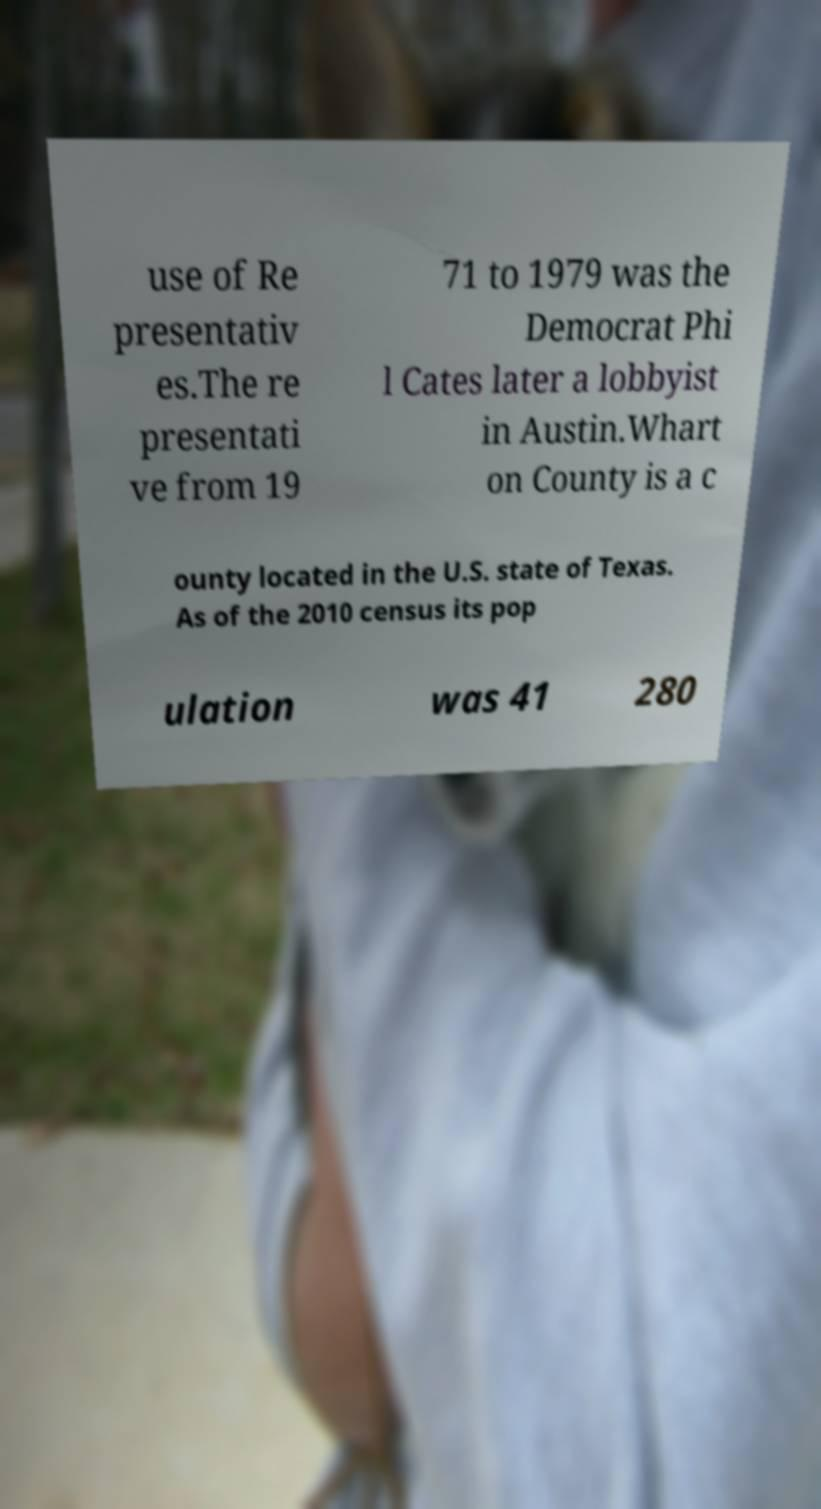Can you accurately transcribe the text from the provided image for me? use of Re presentativ es.The re presentati ve from 19 71 to 1979 was the Democrat Phi l Cates later a lobbyist in Austin.Whart on County is a c ounty located in the U.S. state of Texas. As of the 2010 census its pop ulation was 41 280 